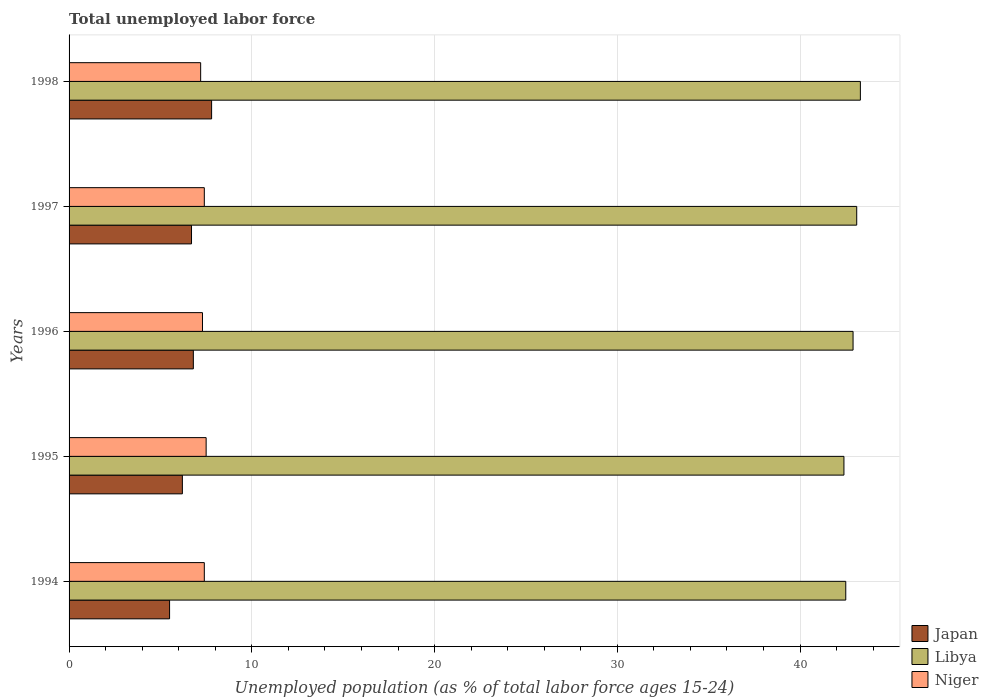How many different coloured bars are there?
Your answer should be very brief. 3. How many groups of bars are there?
Your answer should be very brief. 5. How many bars are there on the 1st tick from the bottom?
Offer a terse response. 3. What is the label of the 4th group of bars from the top?
Offer a terse response. 1995. In how many cases, is the number of bars for a given year not equal to the number of legend labels?
Your response must be concise. 0. What is the percentage of unemployed population in in Japan in 1997?
Offer a very short reply. 6.7. Across all years, what is the maximum percentage of unemployed population in in Japan?
Ensure brevity in your answer.  7.8. Across all years, what is the minimum percentage of unemployed population in in Libya?
Offer a very short reply. 42.4. What is the total percentage of unemployed population in in Libya in the graph?
Keep it short and to the point. 214.2. What is the difference between the percentage of unemployed population in in Niger in 1995 and that in 1996?
Give a very brief answer. 0.2. What is the difference between the percentage of unemployed population in in Libya in 1995 and the percentage of unemployed population in in Japan in 1997?
Make the answer very short. 35.7. What is the average percentage of unemployed population in in Niger per year?
Your answer should be compact. 7.36. In the year 1997, what is the difference between the percentage of unemployed population in in Libya and percentage of unemployed population in in Niger?
Give a very brief answer. 35.7. What is the ratio of the percentage of unemployed population in in Libya in 1994 to that in 1995?
Offer a terse response. 1. What is the difference between the highest and the second highest percentage of unemployed population in in Niger?
Ensure brevity in your answer.  0.1. What is the difference between the highest and the lowest percentage of unemployed population in in Japan?
Ensure brevity in your answer.  2.3. In how many years, is the percentage of unemployed population in in Libya greater than the average percentage of unemployed population in in Libya taken over all years?
Offer a very short reply. 3. What does the 3rd bar from the top in 1994 represents?
Keep it short and to the point. Japan. What does the 1st bar from the bottom in 1997 represents?
Your answer should be very brief. Japan. Is it the case that in every year, the sum of the percentage of unemployed population in in Japan and percentage of unemployed population in in Libya is greater than the percentage of unemployed population in in Niger?
Keep it short and to the point. Yes. Does the graph contain any zero values?
Offer a terse response. No. Does the graph contain grids?
Your answer should be compact. Yes. Where does the legend appear in the graph?
Make the answer very short. Bottom right. How many legend labels are there?
Your answer should be very brief. 3. How are the legend labels stacked?
Your answer should be very brief. Vertical. What is the title of the graph?
Your answer should be compact. Total unemployed labor force. Does "Cyprus" appear as one of the legend labels in the graph?
Your answer should be very brief. No. What is the label or title of the X-axis?
Give a very brief answer. Unemployed population (as % of total labor force ages 15-24). What is the Unemployed population (as % of total labor force ages 15-24) of Japan in 1994?
Your answer should be compact. 5.5. What is the Unemployed population (as % of total labor force ages 15-24) of Libya in 1994?
Make the answer very short. 42.5. What is the Unemployed population (as % of total labor force ages 15-24) in Niger in 1994?
Offer a terse response. 7.4. What is the Unemployed population (as % of total labor force ages 15-24) of Japan in 1995?
Your response must be concise. 6.2. What is the Unemployed population (as % of total labor force ages 15-24) in Libya in 1995?
Provide a succinct answer. 42.4. What is the Unemployed population (as % of total labor force ages 15-24) of Niger in 1995?
Your response must be concise. 7.5. What is the Unemployed population (as % of total labor force ages 15-24) of Japan in 1996?
Give a very brief answer. 6.8. What is the Unemployed population (as % of total labor force ages 15-24) of Libya in 1996?
Ensure brevity in your answer.  42.9. What is the Unemployed population (as % of total labor force ages 15-24) in Niger in 1996?
Your answer should be compact. 7.3. What is the Unemployed population (as % of total labor force ages 15-24) in Japan in 1997?
Ensure brevity in your answer.  6.7. What is the Unemployed population (as % of total labor force ages 15-24) in Libya in 1997?
Your answer should be very brief. 43.1. What is the Unemployed population (as % of total labor force ages 15-24) in Niger in 1997?
Provide a short and direct response. 7.4. What is the Unemployed population (as % of total labor force ages 15-24) in Japan in 1998?
Your answer should be compact. 7.8. What is the Unemployed population (as % of total labor force ages 15-24) in Libya in 1998?
Make the answer very short. 43.3. What is the Unemployed population (as % of total labor force ages 15-24) of Niger in 1998?
Make the answer very short. 7.2. Across all years, what is the maximum Unemployed population (as % of total labor force ages 15-24) of Japan?
Ensure brevity in your answer.  7.8. Across all years, what is the maximum Unemployed population (as % of total labor force ages 15-24) of Libya?
Make the answer very short. 43.3. Across all years, what is the maximum Unemployed population (as % of total labor force ages 15-24) in Niger?
Your answer should be compact. 7.5. Across all years, what is the minimum Unemployed population (as % of total labor force ages 15-24) of Japan?
Make the answer very short. 5.5. Across all years, what is the minimum Unemployed population (as % of total labor force ages 15-24) of Libya?
Offer a terse response. 42.4. Across all years, what is the minimum Unemployed population (as % of total labor force ages 15-24) of Niger?
Ensure brevity in your answer.  7.2. What is the total Unemployed population (as % of total labor force ages 15-24) in Japan in the graph?
Your answer should be very brief. 33. What is the total Unemployed population (as % of total labor force ages 15-24) of Libya in the graph?
Offer a terse response. 214.2. What is the total Unemployed population (as % of total labor force ages 15-24) of Niger in the graph?
Your answer should be compact. 36.8. What is the difference between the Unemployed population (as % of total labor force ages 15-24) of Japan in 1994 and that in 1995?
Your response must be concise. -0.7. What is the difference between the Unemployed population (as % of total labor force ages 15-24) of Libya in 1994 and that in 1995?
Ensure brevity in your answer.  0.1. What is the difference between the Unemployed population (as % of total labor force ages 15-24) in Niger in 1994 and that in 1995?
Provide a succinct answer. -0.1. What is the difference between the Unemployed population (as % of total labor force ages 15-24) in Japan in 1994 and that in 1996?
Offer a very short reply. -1.3. What is the difference between the Unemployed population (as % of total labor force ages 15-24) of Libya in 1994 and that in 1996?
Keep it short and to the point. -0.4. What is the difference between the Unemployed population (as % of total labor force ages 15-24) in Niger in 1994 and that in 1996?
Provide a succinct answer. 0.1. What is the difference between the Unemployed population (as % of total labor force ages 15-24) of Niger in 1994 and that in 1997?
Your response must be concise. 0. What is the difference between the Unemployed population (as % of total labor force ages 15-24) in Japan in 1994 and that in 1998?
Make the answer very short. -2.3. What is the difference between the Unemployed population (as % of total labor force ages 15-24) in Niger in 1994 and that in 1998?
Keep it short and to the point. 0.2. What is the difference between the Unemployed population (as % of total labor force ages 15-24) of Niger in 1995 and that in 1996?
Make the answer very short. 0.2. What is the difference between the Unemployed population (as % of total labor force ages 15-24) of Libya in 1995 and that in 1997?
Offer a terse response. -0.7. What is the difference between the Unemployed population (as % of total labor force ages 15-24) of Niger in 1995 and that in 1997?
Your response must be concise. 0.1. What is the difference between the Unemployed population (as % of total labor force ages 15-24) of Libya in 1995 and that in 1998?
Offer a terse response. -0.9. What is the difference between the Unemployed population (as % of total labor force ages 15-24) of Niger in 1995 and that in 1998?
Offer a very short reply. 0.3. What is the difference between the Unemployed population (as % of total labor force ages 15-24) of Niger in 1996 and that in 1997?
Your response must be concise. -0.1. What is the difference between the Unemployed population (as % of total labor force ages 15-24) in Libya in 1996 and that in 1998?
Your answer should be compact. -0.4. What is the difference between the Unemployed population (as % of total labor force ages 15-24) of Niger in 1996 and that in 1998?
Your answer should be very brief. 0.1. What is the difference between the Unemployed population (as % of total labor force ages 15-24) in Japan in 1997 and that in 1998?
Keep it short and to the point. -1.1. What is the difference between the Unemployed population (as % of total labor force ages 15-24) in Niger in 1997 and that in 1998?
Ensure brevity in your answer.  0.2. What is the difference between the Unemployed population (as % of total labor force ages 15-24) of Japan in 1994 and the Unemployed population (as % of total labor force ages 15-24) of Libya in 1995?
Your answer should be compact. -36.9. What is the difference between the Unemployed population (as % of total labor force ages 15-24) in Japan in 1994 and the Unemployed population (as % of total labor force ages 15-24) in Niger in 1995?
Give a very brief answer. -2. What is the difference between the Unemployed population (as % of total labor force ages 15-24) of Libya in 1994 and the Unemployed population (as % of total labor force ages 15-24) of Niger in 1995?
Your response must be concise. 35. What is the difference between the Unemployed population (as % of total labor force ages 15-24) of Japan in 1994 and the Unemployed population (as % of total labor force ages 15-24) of Libya in 1996?
Keep it short and to the point. -37.4. What is the difference between the Unemployed population (as % of total labor force ages 15-24) of Japan in 1994 and the Unemployed population (as % of total labor force ages 15-24) of Niger in 1996?
Offer a very short reply. -1.8. What is the difference between the Unemployed population (as % of total labor force ages 15-24) in Libya in 1994 and the Unemployed population (as % of total labor force ages 15-24) in Niger in 1996?
Make the answer very short. 35.2. What is the difference between the Unemployed population (as % of total labor force ages 15-24) of Japan in 1994 and the Unemployed population (as % of total labor force ages 15-24) of Libya in 1997?
Keep it short and to the point. -37.6. What is the difference between the Unemployed population (as % of total labor force ages 15-24) in Japan in 1994 and the Unemployed population (as % of total labor force ages 15-24) in Niger in 1997?
Offer a terse response. -1.9. What is the difference between the Unemployed population (as % of total labor force ages 15-24) of Libya in 1994 and the Unemployed population (as % of total labor force ages 15-24) of Niger in 1997?
Provide a short and direct response. 35.1. What is the difference between the Unemployed population (as % of total labor force ages 15-24) in Japan in 1994 and the Unemployed population (as % of total labor force ages 15-24) in Libya in 1998?
Your answer should be very brief. -37.8. What is the difference between the Unemployed population (as % of total labor force ages 15-24) in Japan in 1994 and the Unemployed population (as % of total labor force ages 15-24) in Niger in 1998?
Make the answer very short. -1.7. What is the difference between the Unemployed population (as % of total labor force ages 15-24) of Libya in 1994 and the Unemployed population (as % of total labor force ages 15-24) of Niger in 1998?
Provide a succinct answer. 35.3. What is the difference between the Unemployed population (as % of total labor force ages 15-24) of Japan in 1995 and the Unemployed population (as % of total labor force ages 15-24) of Libya in 1996?
Offer a terse response. -36.7. What is the difference between the Unemployed population (as % of total labor force ages 15-24) of Libya in 1995 and the Unemployed population (as % of total labor force ages 15-24) of Niger in 1996?
Offer a terse response. 35.1. What is the difference between the Unemployed population (as % of total labor force ages 15-24) in Japan in 1995 and the Unemployed population (as % of total labor force ages 15-24) in Libya in 1997?
Provide a succinct answer. -36.9. What is the difference between the Unemployed population (as % of total labor force ages 15-24) of Japan in 1995 and the Unemployed population (as % of total labor force ages 15-24) of Niger in 1997?
Provide a short and direct response. -1.2. What is the difference between the Unemployed population (as % of total labor force ages 15-24) in Libya in 1995 and the Unemployed population (as % of total labor force ages 15-24) in Niger in 1997?
Offer a very short reply. 35. What is the difference between the Unemployed population (as % of total labor force ages 15-24) of Japan in 1995 and the Unemployed population (as % of total labor force ages 15-24) of Libya in 1998?
Offer a terse response. -37.1. What is the difference between the Unemployed population (as % of total labor force ages 15-24) of Japan in 1995 and the Unemployed population (as % of total labor force ages 15-24) of Niger in 1998?
Your answer should be very brief. -1. What is the difference between the Unemployed population (as % of total labor force ages 15-24) of Libya in 1995 and the Unemployed population (as % of total labor force ages 15-24) of Niger in 1998?
Your answer should be very brief. 35.2. What is the difference between the Unemployed population (as % of total labor force ages 15-24) of Japan in 1996 and the Unemployed population (as % of total labor force ages 15-24) of Libya in 1997?
Provide a short and direct response. -36.3. What is the difference between the Unemployed population (as % of total labor force ages 15-24) in Japan in 1996 and the Unemployed population (as % of total labor force ages 15-24) in Niger in 1997?
Your answer should be very brief. -0.6. What is the difference between the Unemployed population (as % of total labor force ages 15-24) in Libya in 1996 and the Unemployed population (as % of total labor force ages 15-24) in Niger in 1997?
Make the answer very short. 35.5. What is the difference between the Unemployed population (as % of total labor force ages 15-24) in Japan in 1996 and the Unemployed population (as % of total labor force ages 15-24) in Libya in 1998?
Offer a terse response. -36.5. What is the difference between the Unemployed population (as % of total labor force ages 15-24) of Libya in 1996 and the Unemployed population (as % of total labor force ages 15-24) of Niger in 1998?
Ensure brevity in your answer.  35.7. What is the difference between the Unemployed population (as % of total labor force ages 15-24) of Japan in 1997 and the Unemployed population (as % of total labor force ages 15-24) of Libya in 1998?
Ensure brevity in your answer.  -36.6. What is the difference between the Unemployed population (as % of total labor force ages 15-24) of Japan in 1997 and the Unemployed population (as % of total labor force ages 15-24) of Niger in 1998?
Your answer should be compact. -0.5. What is the difference between the Unemployed population (as % of total labor force ages 15-24) of Libya in 1997 and the Unemployed population (as % of total labor force ages 15-24) of Niger in 1998?
Your answer should be very brief. 35.9. What is the average Unemployed population (as % of total labor force ages 15-24) of Japan per year?
Provide a short and direct response. 6.6. What is the average Unemployed population (as % of total labor force ages 15-24) in Libya per year?
Your answer should be compact. 42.84. What is the average Unemployed population (as % of total labor force ages 15-24) in Niger per year?
Your answer should be compact. 7.36. In the year 1994, what is the difference between the Unemployed population (as % of total labor force ages 15-24) in Japan and Unemployed population (as % of total labor force ages 15-24) in Libya?
Give a very brief answer. -37. In the year 1994, what is the difference between the Unemployed population (as % of total labor force ages 15-24) of Libya and Unemployed population (as % of total labor force ages 15-24) of Niger?
Ensure brevity in your answer.  35.1. In the year 1995, what is the difference between the Unemployed population (as % of total labor force ages 15-24) in Japan and Unemployed population (as % of total labor force ages 15-24) in Libya?
Provide a succinct answer. -36.2. In the year 1995, what is the difference between the Unemployed population (as % of total labor force ages 15-24) of Libya and Unemployed population (as % of total labor force ages 15-24) of Niger?
Provide a succinct answer. 34.9. In the year 1996, what is the difference between the Unemployed population (as % of total labor force ages 15-24) in Japan and Unemployed population (as % of total labor force ages 15-24) in Libya?
Your answer should be compact. -36.1. In the year 1996, what is the difference between the Unemployed population (as % of total labor force ages 15-24) in Libya and Unemployed population (as % of total labor force ages 15-24) in Niger?
Your response must be concise. 35.6. In the year 1997, what is the difference between the Unemployed population (as % of total labor force ages 15-24) of Japan and Unemployed population (as % of total labor force ages 15-24) of Libya?
Keep it short and to the point. -36.4. In the year 1997, what is the difference between the Unemployed population (as % of total labor force ages 15-24) of Libya and Unemployed population (as % of total labor force ages 15-24) of Niger?
Give a very brief answer. 35.7. In the year 1998, what is the difference between the Unemployed population (as % of total labor force ages 15-24) of Japan and Unemployed population (as % of total labor force ages 15-24) of Libya?
Ensure brevity in your answer.  -35.5. In the year 1998, what is the difference between the Unemployed population (as % of total labor force ages 15-24) in Japan and Unemployed population (as % of total labor force ages 15-24) in Niger?
Ensure brevity in your answer.  0.6. In the year 1998, what is the difference between the Unemployed population (as % of total labor force ages 15-24) of Libya and Unemployed population (as % of total labor force ages 15-24) of Niger?
Make the answer very short. 36.1. What is the ratio of the Unemployed population (as % of total labor force ages 15-24) in Japan in 1994 to that in 1995?
Your answer should be very brief. 0.89. What is the ratio of the Unemployed population (as % of total labor force ages 15-24) in Niger in 1994 to that in 1995?
Your answer should be compact. 0.99. What is the ratio of the Unemployed population (as % of total labor force ages 15-24) in Japan in 1994 to that in 1996?
Your answer should be very brief. 0.81. What is the ratio of the Unemployed population (as % of total labor force ages 15-24) of Niger in 1994 to that in 1996?
Your answer should be very brief. 1.01. What is the ratio of the Unemployed population (as % of total labor force ages 15-24) of Japan in 1994 to that in 1997?
Ensure brevity in your answer.  0.82. What is the ratio of the Unemployed population (as % of total labor force ages 15-24) of Libya in 1994 to that in 1997?
Make the answer very short. 0.99. What is the ratio of the Unemployed population (as % of total labor force ages 15-24) of Japan in 1994 to that in 1998?
Give a very brief answer. 0.71. What is the ratio of the Unemployed population (as % of total labor force ages 15-24) in Libya in 1994 to that in 1998?
Offer a very short reply. 0.98. What is the ratio of the Unemployed population (as % of total labor force ages 15-24) of Niger in 1994 to that in 1998?
Make the answer very short. 1.03. What is the ratio of the Unemployed population (as % of total labor force ages 15-24) in Japan in 1995 to that in 1996?
Provide a short and direct response. 0.91. What is the ratio of the Unemployed population (as % of total labor force ages 15-24) in Libya in 1995 to that in 1996?
Your answer should be very brief. 0.99. What is the ratio of the Unemployed population (as % of total labor force ages 15-24) in Niger in 1995 to that in 1996?
Give a very brief answer. 1.03. What is the ratio of the Unemployed population (as % of total labor force ages 15-24) in Japan in 1995 to that in 1997?
Provide a short and direct response. 0.93. What is the ratio of the Unemployed population (as % of total labor force ages 15-24) of Libya in 1995 to that in 1997?
Provide a short and direct response. 0.98. What is the ratio of the Unemployed population (as % of total labor force ages 15-24) of Niger in 1995 to that in 1997?
Make the answer very short. 1.01. What is the ratio of the Unemployed population (as % of total labor force ages 15-24) in Japan in 1995 to that in 1998?
Provide a short and direct response. 0.79. What is the ratio of the Unemployed population (as % of total labor force ages 15-24) in Libya in 1995 to that in 1998?
Your answer should be very brief. 0.98. What is the ratio of the Unemployed population (as % of total labor force ages 15-24) in Niger in 1995 to that in 1998?
Your response must be concise. 1.04. What is the ratio of the Unemployed population (as % of total labor force ages 15-24) in Japan in 1996 to that in 1997?
Your answer should be very brief. 1.01. What is the ratio of the Unemployed population (as % of total labor force ages 15-24) in Libya in 1996 to that in 1997?
Provide a succinct answer. 1. What is the ratio of the Unemployed population (as % of total labor force ages 15-24) of Niger in 1996 to that in 1997?
Offer a very short reply. 0.99. What is the ratio of the Unemployed population (as % of total labor force ages 15-24) of Japan in 1996 to that in 1998?
Keep it short and to the point. 0.87. What is the ratio of the Unemployed population (as % of total labor force ages 15-24) of Niger in 1996 to that in 1998?
Keep it short and to the point. 1.01. What is the ratio of the Unemployed population (as % of total labor force ages 15-24) in Japan in 1997 to that in 1998?
Ensure brevity in your answer.  0.86. What is the ratio of the Unemployed population (as % of total labor force ages 15-24) in Niger in 1997 to that in 1998?
Your response must be concise. 1.03. What is the difference between the highest and the second highest Unemployed population (as % of total labor force ages 15-24) of Japan?
Give a very brief answer. 1. What is the difference between the highest and the lowest Unemployed population (as % of total labor force ages 15-24) of Niger?
Make the answer very short. 0.3. 